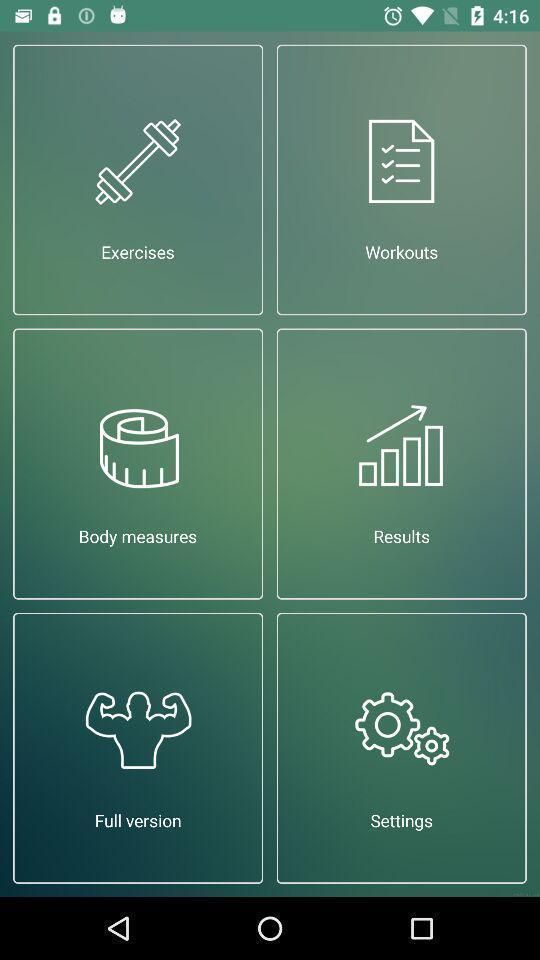Explain the elements present in this screenshot. Screen displaying the icons of a fitness app. 